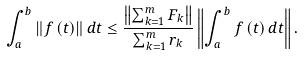<formula> <loc_0><loc_0><loc_500><loc_500>\int _ { a } ^ { b } \left \| f \left ( t \right ) \right \| d t \leq \frac { \left \| \sum _ { k = 1 } ^ { m } F _ { k } \right \| } { \sum _ { k = 1 } ^ { m } r _ { k } } \left \| \int _ { a } ^ { b } f \left ( t \right ) d t \right \| .</formula> 